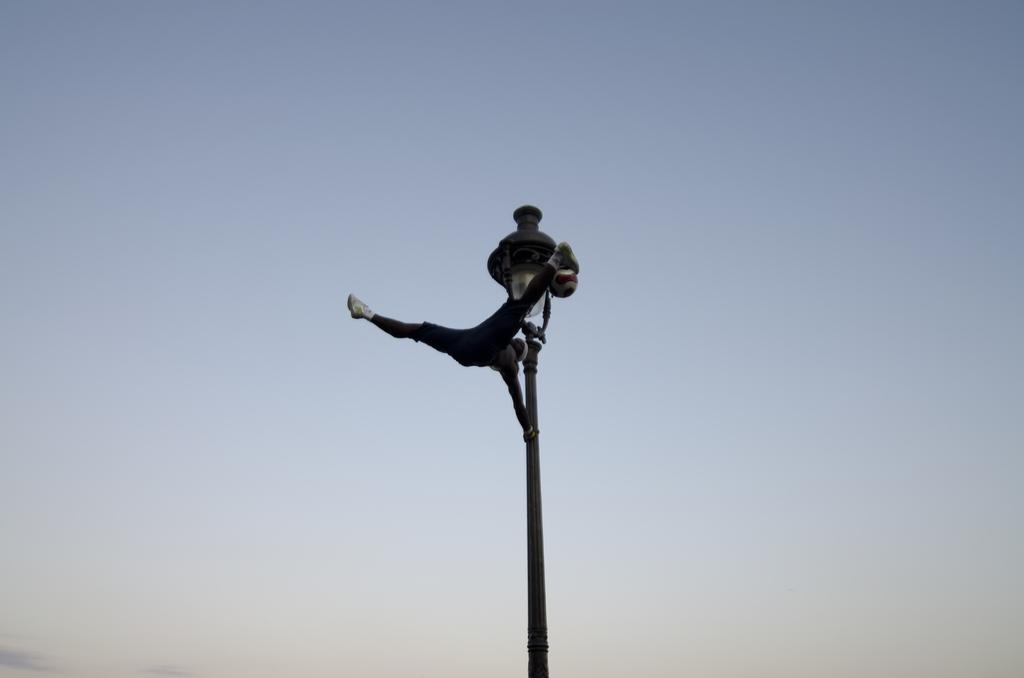What structure can be seen in the image? There is a light pole in the image. What is the person in the image doing with the light pole? A person is holding the light pole. What is the person wearing in the image? The person is wearing a black dress. What can be seen in the background of the image? The sky is visible in the background of the image. What type of lettuce is being used to butter the person's hair in the image? There is no lettuce or butter present in the image, and no one's hair is being buttered. 